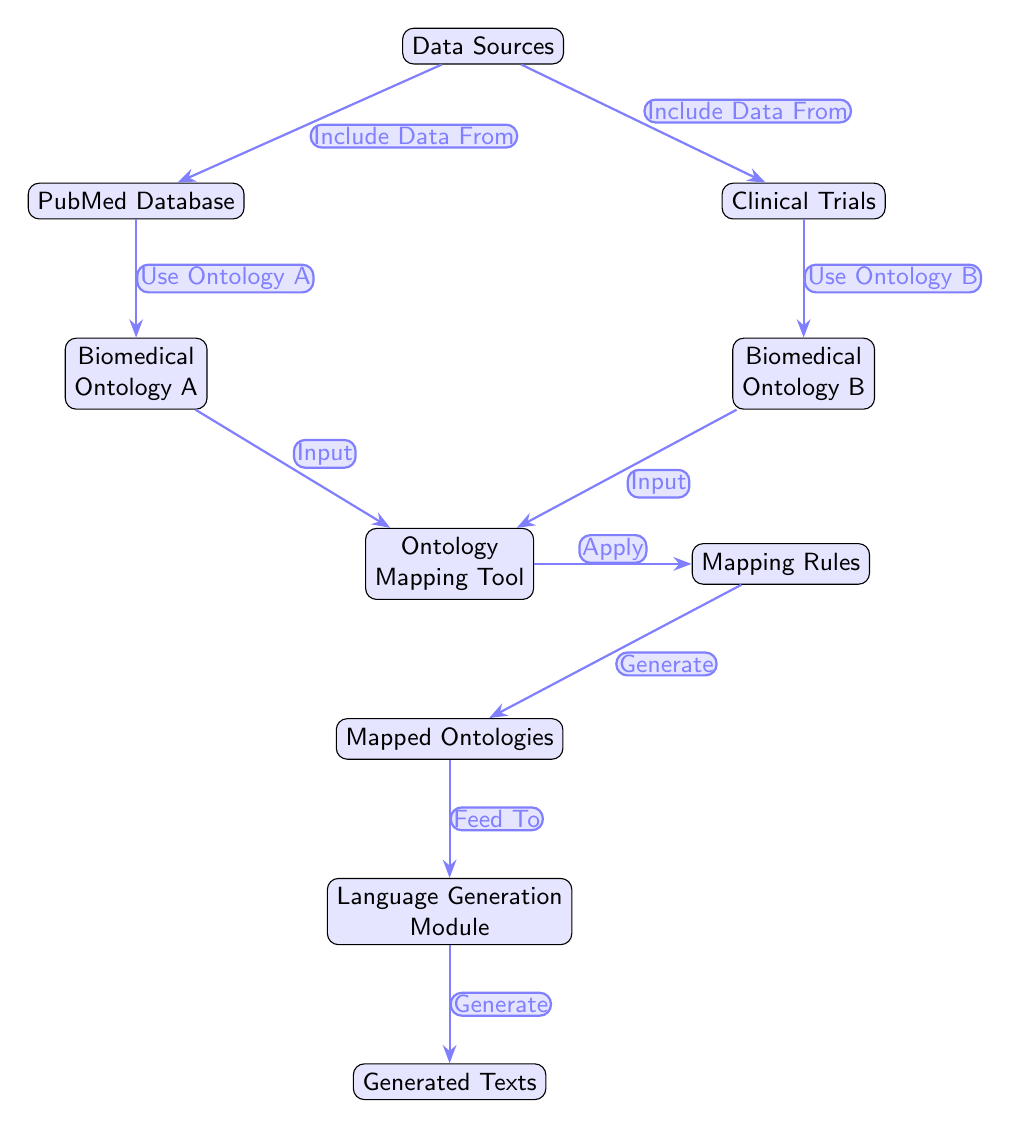What are the data sources mentioned in the diagram? The diagram lists two specific data sources: PubMed Database and Clinical Trials, both stemming directly from the main Data Sources node.
Answer: PubMed Database, Clinical Trials How many nodes are present in the diagram? Counting the nodes in the diagram, we identify 9 main nodes that represent various stages in the mapping process.
Answer: 9 What is the output of the Ontology Mapping Tool? The Ontology Mapping Tool outputs Mapped Ontologies according to the flow shown in the diagram, signifying its result in the mapping process.
Answer: Mapped Ontologies Which node feeds into the Language Generation Module? The diagram indicates that the input to the Language Generation Module comes directly from Mapped Ontologies, which is the node directly above it in the flow.
Answer: Mapped Ontologies What is the function applied in the Ontology Mapping Tool? The function applied by the Ontology Mapping Tool, as stated in the diagram, is to apply Mapping Rules which guide the mapping process.
Answer: Apply How does the data from the PubMed Database influence the process? Data from the PubMed Database is used to derive Biomedical Ontology A, directly affecting the input into the Ontology Mapping Tool.
Answer: Use Ontology A What are the roles of the Mapped Ontologies in this diagram? The Mapped Ontologies serve as the critical intermediary that directly feeds into the Language Generation Module, facilitating the generation of texts.
Answer: Feed To What comes after the Application of Mapping Rules? Following the application of Mapping Rules in the process, the next step is the generation of Mapped Ontologies, which indicates a continuation in the workflow.
Answer: Generate 